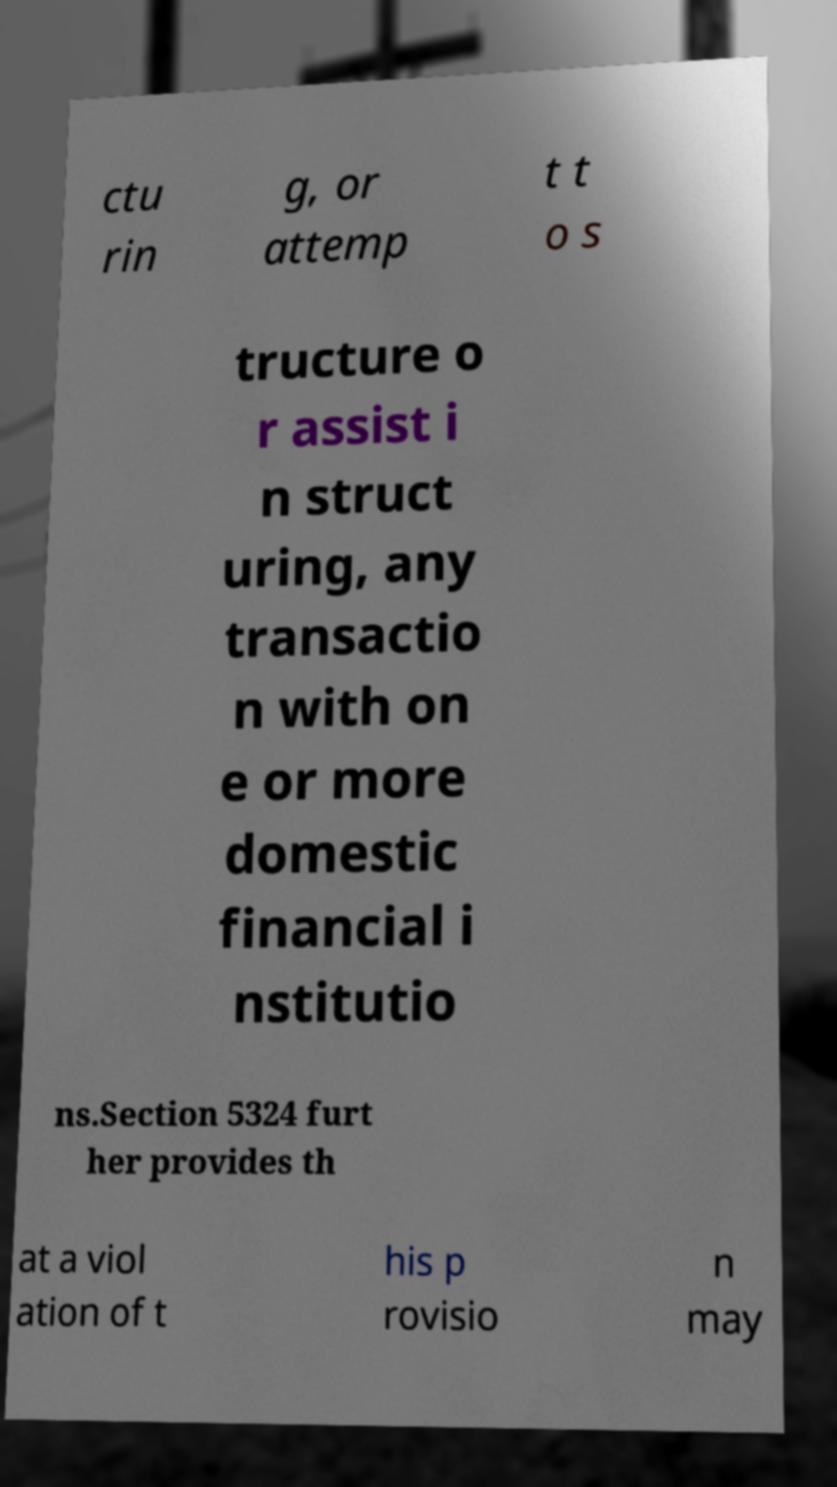Can you accurately transcribe the text from the provided image for me? ctu rin g, or attemp t t o s tructure o r assist i n struct uring, any transactio n with on e or more domestic financial i nstitutio ns.Section 5324 furt her provides th at a viol ation of t his p rovisio n may 